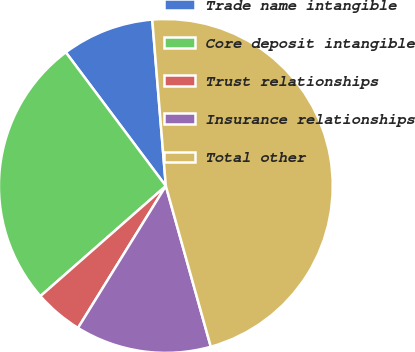<chart> <loc_0><loc_0><loc_500><loc_500><pie_chart><fcel>Trade name intangible<fcel>Core deposit intangible<fcel>Trust relationships<fcel>Insurance relationships<fcel>Total other<nl><fcel>8.93%<fcel>26.25%<fcel>4.71%<fcel>13.16%<fcel>46.96%<nl></chart> 